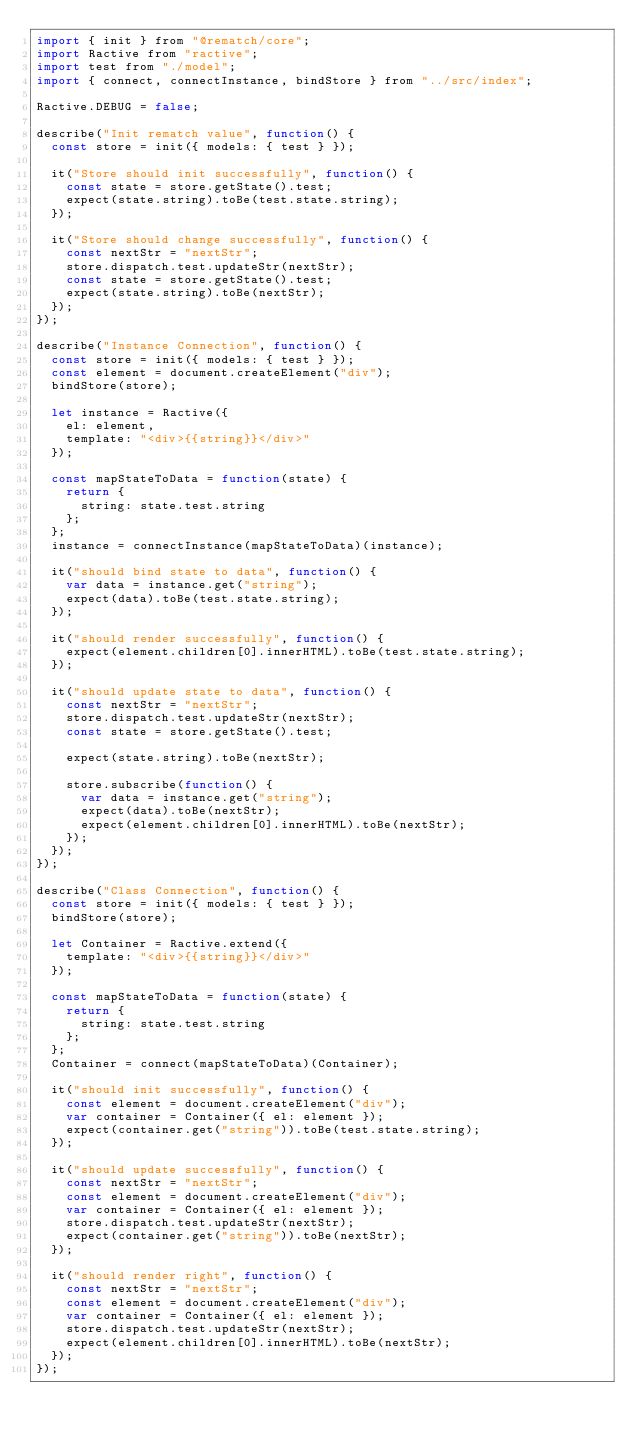<code> <loc_0><loc_0><loc_500><loc_500><_JavaScript_>import { init } from "@rematch/core";
import Ractive from "ractive";
import test from "./model";
import { connect, connectInstance, bindStore } from "../src/index";

Ractive.DEBUG = false;

describe("Init rematch value", function() {
  const store = init({ models: { test } });

  it("Store should init successfully", function() {
    const state = store.getState().test;
    expect(state.string).toBe(test.state.string);
  });

  it("Store should change successfully", function() {
    const nextStr = "nextStr";
    store.dispatch.test.updateStr(nextStr);
    const state = store.getState().test;
    expect(state.string).toBe(nextStr);
  });
});

describe("Instance Connection", function() {
  const store = init({ models: { test } });
  const element = document.createElement("div");
  bindStore(store);

  let instance = Ractive({
    el: element,
    template: "<div>{{string}}</div>"
  });

  const mapStateToData = function(state) {
    return {
      string: state.test.string
    };
  };
  instance = connectInstance(mapStateToData)(instance);

  it("should bind state to data", function() {
    var data = instance.get("string");
    expect(data).toBe(test.state.string);
  });

  it("should render successfully", function() {
    expect(element.children[0].innerHTML).toBe(test.state.string);
  });

  it("should update state to data", function() {
    const nextStr = "nextStr";
    store.dispatch.test.updateStr(nextStr);
    const state = store.getState().test;

    expect(state.string).toBe(nextStr);

    store.subscribe(function() {
      var data = instance.get("string");
      expect(data).toBe(nextStr);
      expect(element.children[0].innerHTML).toBe(nextStr);
    });
  });
});

describe("Class Connection", function() {
  const store = init({ models: { test } });
  bindStore(store);

  let Container = Ractive.extend({
    template: "<div>{{string}}</div>"
  });

  const mapStateToData = function(state) {
    return {
      string: state.test.string
    };
  };
  Container = connect(mapStateToData)(Container);

  it("should init successfully", function() {
    const element = document.createElement("div");
    var container = Container({ el: element });
    expect(container.get("string")).toBe(test.state.string);
  });

  it("should update successfully", function() {
    const nextStr = "nextStr";
    const element = document.createElement("div");
    var container = Container({ el: element });
    store.dispatch.test.updateStr(nextStr);
    expect(container.get("string")).toBe(nextStr);
  });

  it("should render right", function() {
    const nextStr = "nextStr";
    const element = document.createElement("div");
    var container = Container({ el: element });
    store.dispatch.test.updateStr(nextStr);
    expect(element.children[0].innerHTML).toBe(nextStr);
  });
});
</code> 